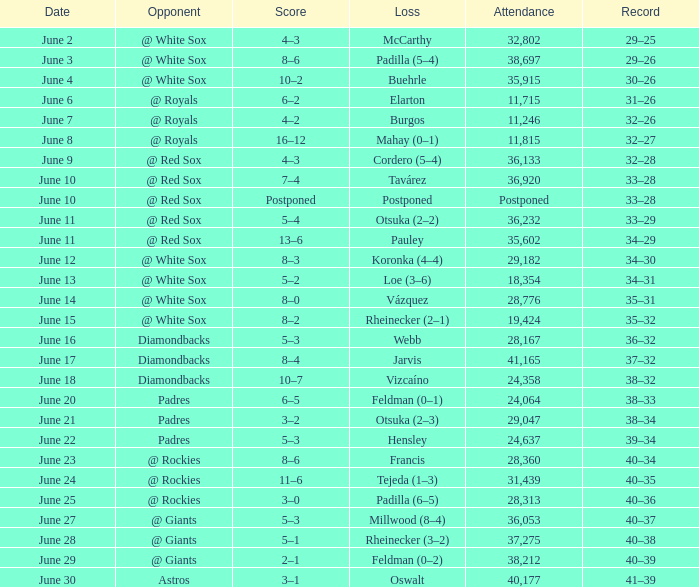When did tavárez lose? June 10. 